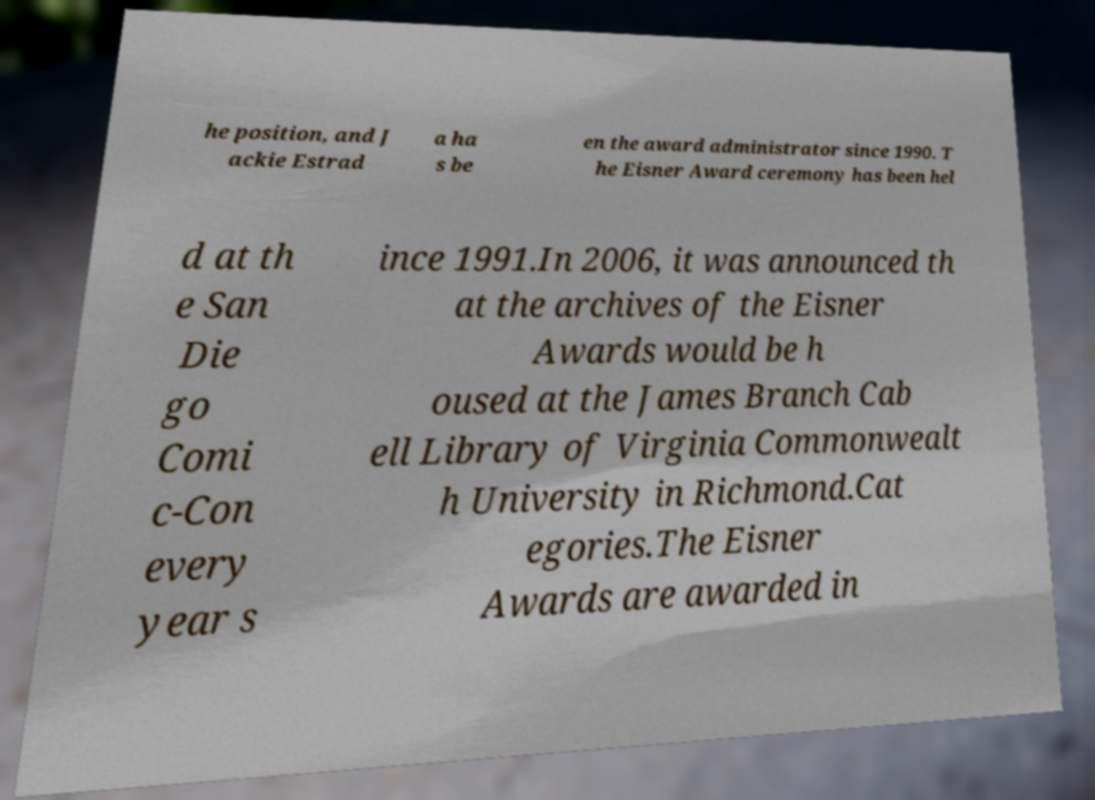Can you accurately transcribe the text from the provided image for me? he position, and J ackie Estrad a ha s be en the award administrator since 1990. T he Eisner Award ceremony has been hel d at th e San Die go Comi c-Con every year s ince 1991.In 2006, it was announced th at the archives of the Eisner Awards would be h oused at the James Branch Cab ell Library of Virginia Commonwealt h University in Richmond.Cat egories.The Eisner Awards are awarded in 